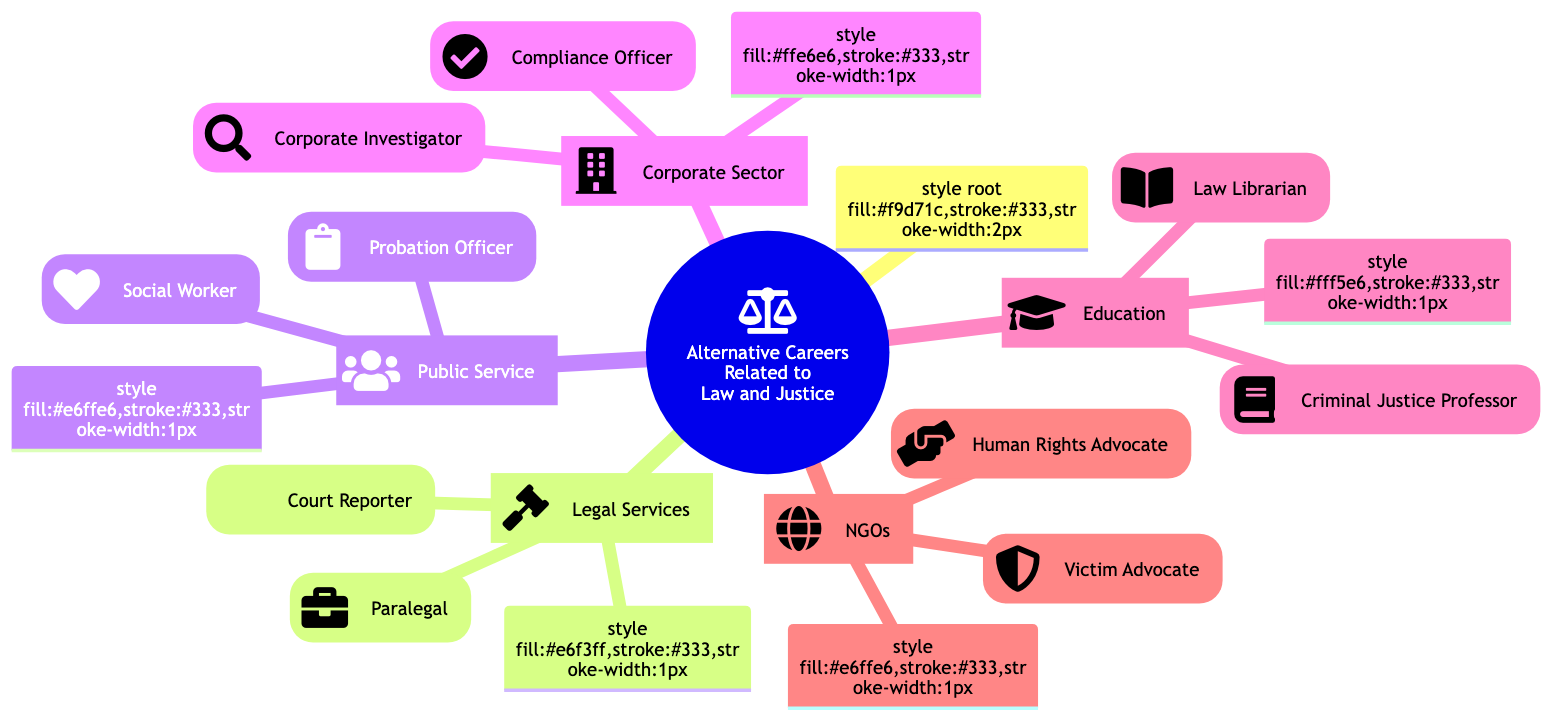What are the two main branches off of "Alternative Careers Related to Law and Justice"? The diagram shows "Legal Services" and "Public Service" as the first two branches connected to the central idea of "Alternative Careers Related to Law and Justice".
Answer: Legal Services, Public Service How many sub-branches does "Corporate Sector" have? The "Corporate Sector" branch has two sub-branches listed: "Compliance Officer" and "Corporate Investigator". Therefore, it has two sub-branches.
Answer: 2 What is the role of a Paralegal? In the diagram, the role of a Paralegal is defined as assisting lawyers in preparing for trials or hearings, which is directly stated in the details of that sub-branch.
Answer: Assist lawyers Which profession helps support victims of crimes according to the diagram? The diagram lists "Victim Advocate" as the specific profession that supports victims of crimes through the legal process, as detailed in its sub-branch.
Answer: Victim Advocate What is the relationship between "Social Worker" and "Public Service"? The "Social Worker" profession is categorized as a sub-branch under the "Public Service" branch, indicating that it is a role within that area.
Answer: Sub-branch How many total main branches are present in the diagram? The diagram has five main branches labeled: "Legal Services", "Public Service", "Corporate Sector", "Education", and "Non-Governmental Organizations (NGOs)", which sums up to five branches.
Answer: 5 What profession is associated with ensuring companies adhere to legal standards? The diagram explicitly states that the role of the "Compliance Officer" is to ensure that companies adhere to legal standards and regulations.
Answer: Compliance Officer In which branch can you find "Criminal Justice Professor"? "Criminal Justice Professor" is located in the "Education" main branch of the diagram, as stated in its respective categorization.
Answer: Education What two roles are listed under the "Non-Governmental Organizations (NGOs)" branch? The roles listed under "Non-Governmental Organizations (NGOs)" are "Human Rights Advocate" and "Victim Advocate", each defined as sub-branches under this main category.
Answer: Human Rights Advocate, Victim Advocate What does a Court Reporter do, based on the diagram? The diagram outlines that a Court Reporter transcribes court proceedings verbatim, presenting the job's focus and responsibility.
Answer: Transcribe court proceedings 